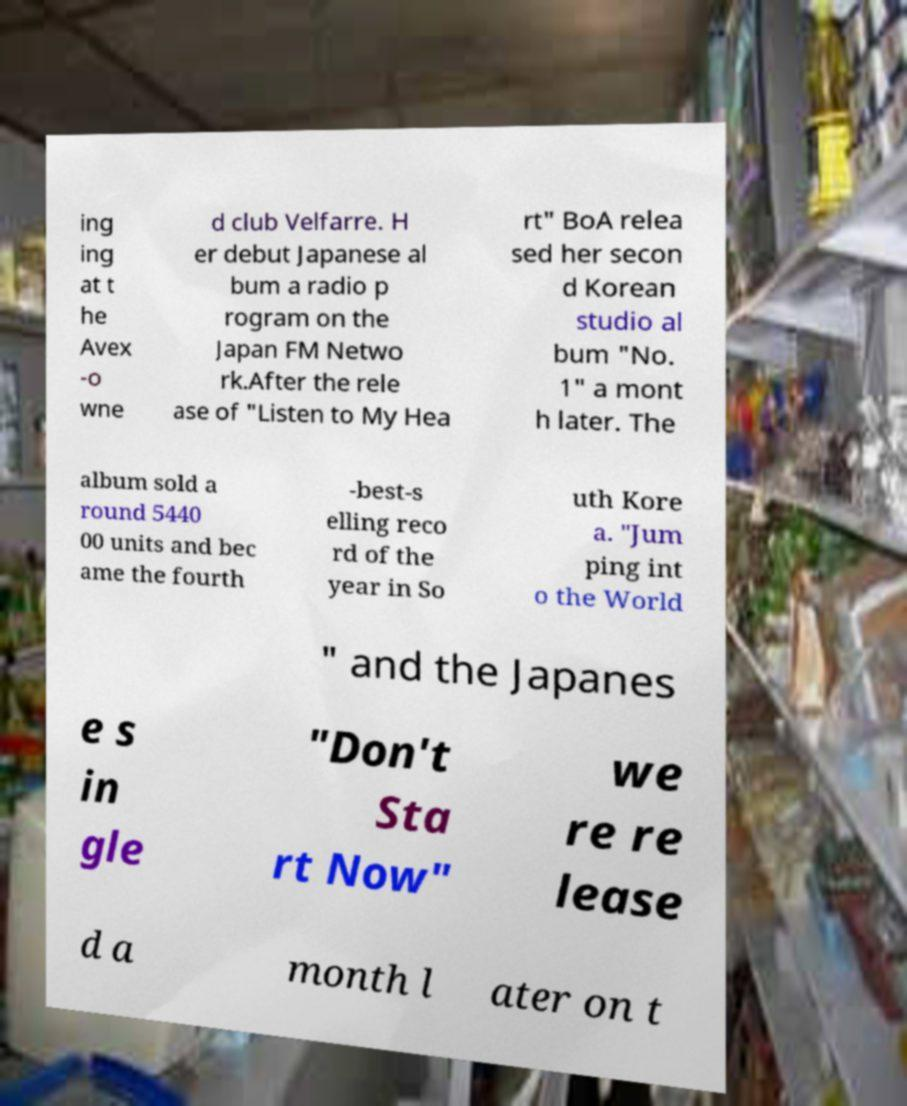Could you extract and type out the text from this image? ing ing at t he Avex -o wne d club Velfarre. H er debut Japanese al bum a radio p rogram on the Japan FM Netwo rk.After the rele ase of "Listen to My Hea rt" BoA relea sed her secon d Korean studio al bum "No. 1" a mont h later. The album sold a round 5440 00 units and bec ame the fourth -best-s elling reco rd of the year in So uth Kore a. "Jum ping int o the World " and the Japanes e s in gle "Don't Sta rt Now" we re re lease d a month l ater on t 